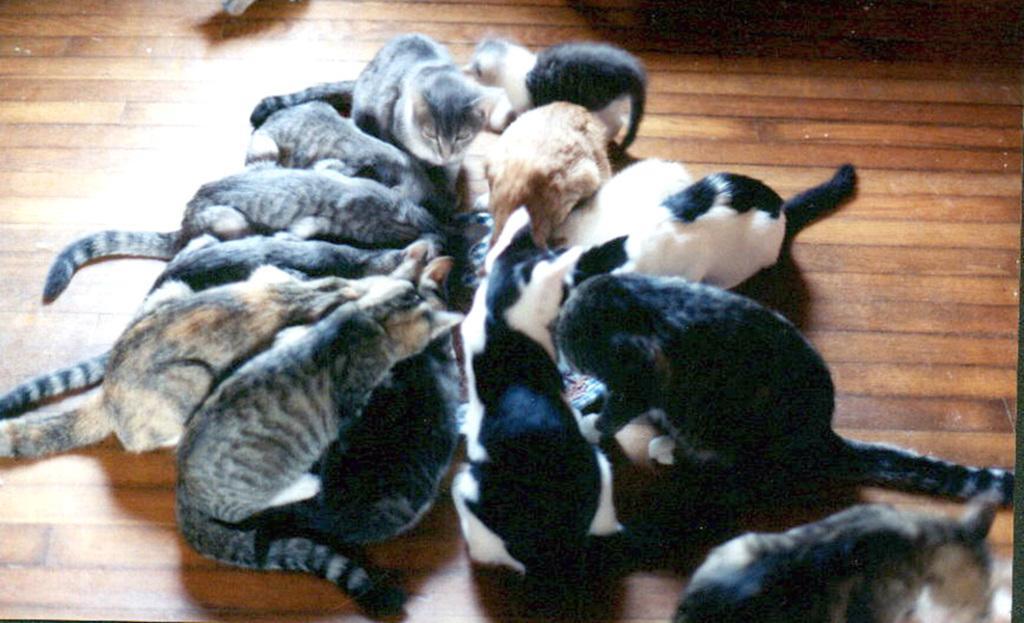How would you summarize this image in a sentence or two? In the picture I can see many cats on the wooden floor. 